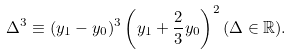Convert formula to latex. <formula><loc_0><loc_0><loc_500><loc_500>\Delta ^ { 3 } \equiv ( y _ { 1 } - y _ { 0 } ) ^ { 3 } \left ( y _ { 1 } + \frac { 2 } { 3 } y _ { 0 } \right ) ^ { 2 } ( \Delta \in { \mathbb { R } } ) .</formula> 